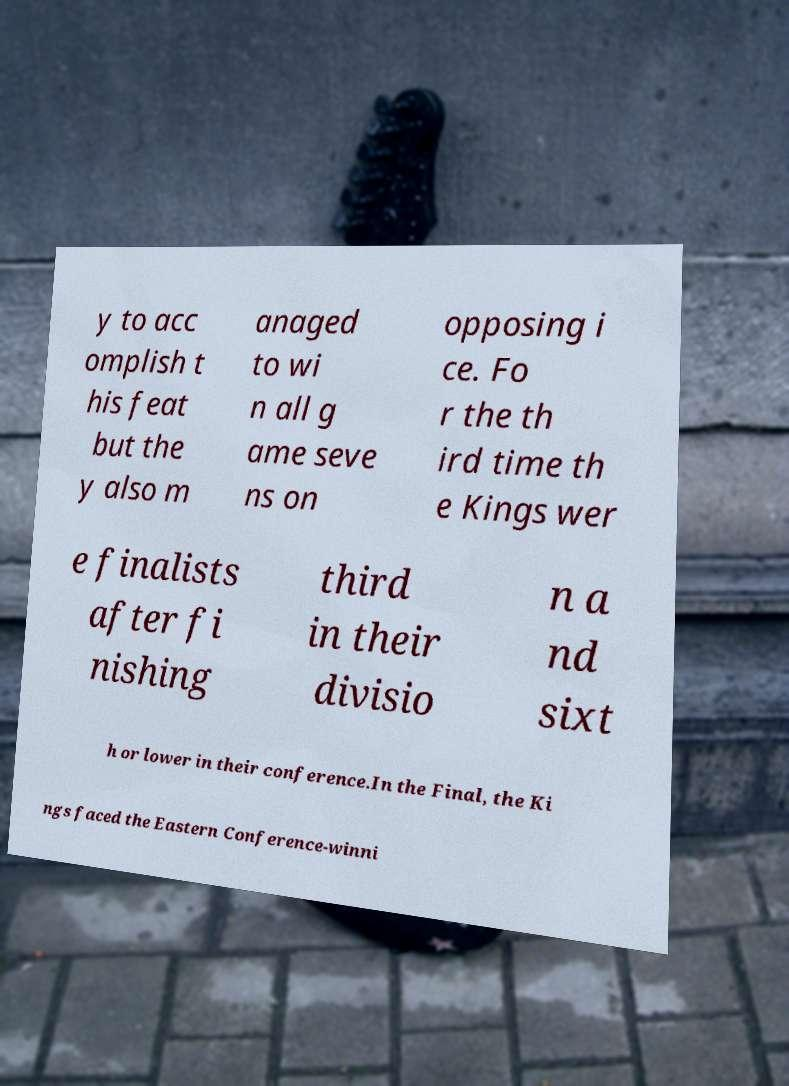There's text embedded in this image that I need extracted. Can you transcribe it verbatim? y to acc omplish t his feat but the y also m anaged to wi n all g ame seve ns on opposing i ce. Fo r the th ird time th e Kings wer e finalists after fi nishing third in their divisio n a nd sixt h or lower in their conference.In the Final, the Ki ngs faced the Eastern Conference-winni 